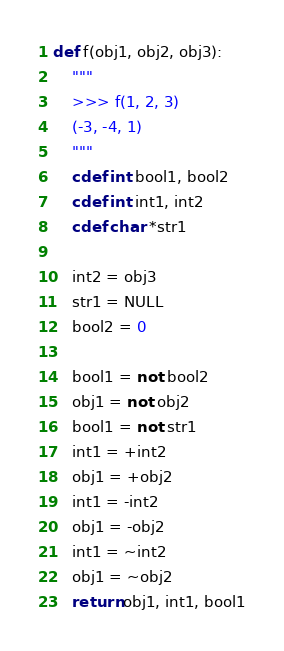Convert code to text. <code><loc_0><loc_0><loc_500><loc_500><_Cython_>def f(obj1, obj2, obj3):
    """
    >>> f(1, 2, 3)
    (-3, -4, 1)
    """
    cdef int bool1, bool2
    cdef int int1, int2
    cdef char *str1

    int2 = obj3
    str1 = NULL
    bool2 = 0

    bool1 = not bool2
    obj1 = not obj2
    bool1 = not str1
    int1 = +int2
    obj1 = +obj2
    int1 = -int2
    obj1 = -obj2
    int1 = ~int2
    obj1 = ~obj2
    return obj1, int1, bool1
</code> 